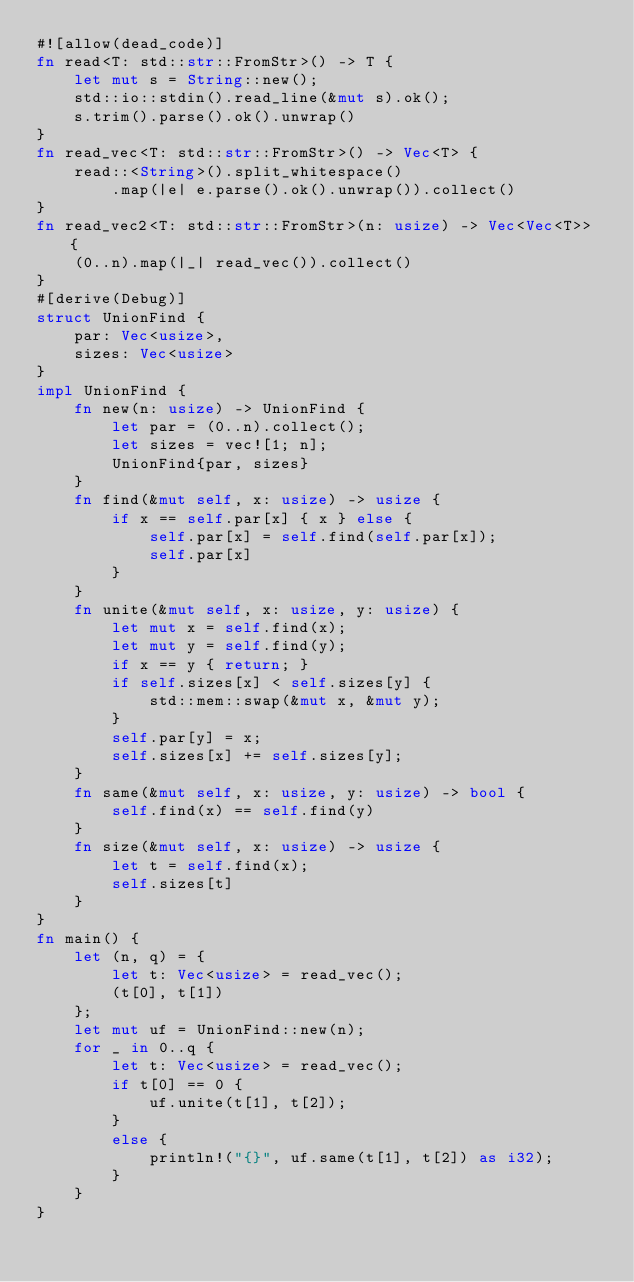<code> <loc_0><loc_0><loc_500><loc_500><_Rust_>#![allow(dead_code)]
fn read<T: std::str::FromStr>() -> T {
    let mut s = String::new();
    std::io::stdin().read_line(&mut s).ok();
    s.trim().parse().ok().unwrap()
}
fn read_vec<T: std::str::FromStr>() -> Vec<T> {
    read::<String>().split_whitespace()
        .map(|e| e.parse().ok().unwrap()).collect()
}
fn read_vec2<T: std::str::FromStr>(n: usize) -> Vec<Vec<T>> {
    (0..n).map(|_| read_vec()).collect()
}
#[derive(Debug)]
struct UnionFind {
    par: Vec<usize>,
    sizes: Vec<usize>
}
impl UnionFind {
    fn new(n: usize) -> UnionFind {
        let par = (0..n).collect();
        let sizes = vec![1; n];
        UnionFind{par, sizes}
    }
    fn find(&mut self, x: usize) -> usize {
        if x == self.par[x] { x } else {
            self.par[x] = self.find(self.par[x]);
            self.par[x]
        }
    }
    fn unite(&mut self, x: usize, y: usize) {
        let mut x = self.find(x);
        let mut y = self.find(y);
        if x == y { return; }
        if self.sizes[x] < self.sizes[y] {
            std::mem::swap(&mut x, &mut y);
        }
        self.par[y] = x;
        self.sizes[x] += self.sizes[y];
    }
    fn same(&mut self, x: usize, y: usize) -> bool {
        self.find(x) == self.find(y)
    }
    fn size(&mut self, x: usize) -> usize {
        let t = self.find(x);
        self.sizes[t]
    }
}
fn main() {
    let (n, q) = {
        let t: Vec<usize> = read_vec();
        (t[0], t[1])
    };
    let mut uf = UnionFind::new(n);
    for _ in 0..q {
        let t: Vec<usize> = read_vec();
        if t[0] == 0 {
            uf.unite(t[1], t[2]);
        }
        else {
            println!("{}", uf.same(t[1], t[2]) as i32);
        }
    }
}
</code> 